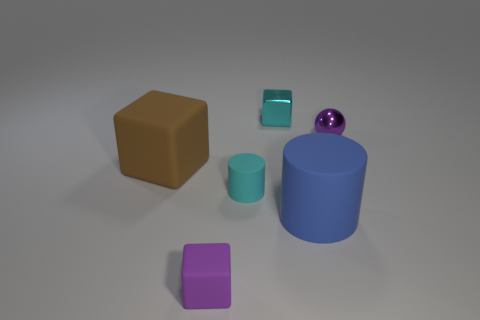Add 2 big gray shiny cylinders. How many objects exist? 8 Subtract all purple blocks. How many blocks are left? 2 Subtract 1 blocks. How many blocks are left? 2 Subtract all blue cylinders. How many cylinders are left? 1 Subtract all red cylinders. Subtract all purple blocks. How many cylinders are left? 2 Subtract all large blue things. Subtract all rubber cylinders. How many objects are left? 3 Add 5 small metal objects. How many small metal objects are left? 7 Add 6 red cubes. How many red cubes exist? 6 Subtract 0 yellow cylinders. How many objects are left? 6 Subtract all cylinders. How many objects are left? 4 